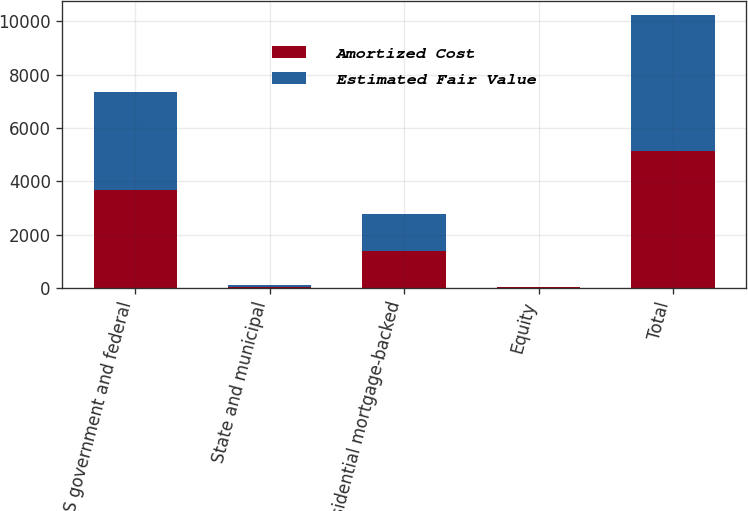Convert chart. <chart><loc_0><loc_0><loc_500><loc_500><stacked_bar_chart><ecel><fcel>US government and federal<fcel>State and municipal<fcel>Residential mortgage-backed<fcel>Equity<fcel>Total<nl><fcel>Amortized Cost<fcel>3676<fcel>47<fcel>1400<fcel>15<fcel>5138<nl><fcel>Estimated Fair Value<fcel>3676<fcel>46<fcel>1373<fcel>15<fcel>5110<nl></chart> 